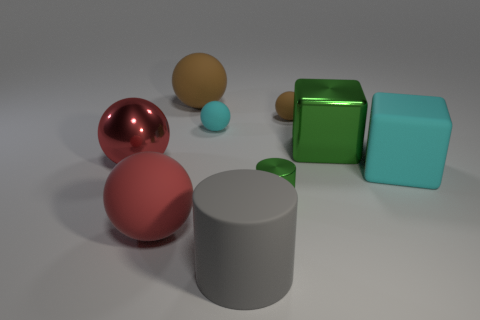Is the shape of the small metallic thing the same as the red shiny object?
Your response must be concise. No. Are there any other things that are the same color as the small metal cylinder?
Make the answer very short. Yes. What color is the other big metallic object that is the same shape as the large brown object?
Offer a very short reply. Red. Is the number of rubber things that are on the left side of the big matte cube greater than the number of metal things?
Make the answer very short. Yes. There is a big shiny object right of the small brown ball; what is its color?
Make the answer very short. Green. Do the matte cylinder and the metal block have the same size?
Provide a short and direct response. Yes. The gray matte cylinder has what size?
Make the answer very short. Large. There is a big object that is the same color as the tiny metallic thing; what shape is it?
Your answer should be very brief. Cube. Are there more purple shiny cylinders than small metallic things?
Your answer should be very brief. No. What color is the tiny thing in front of the cyan thing that is to the left of the green object to the left of the big green shiny cube?
Provide a short and direct response. Green. 